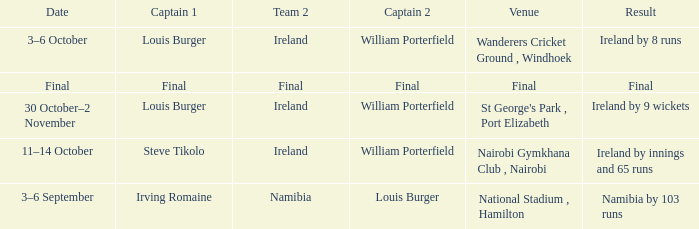Which Result has a Captain 2 of louis burger? Namibia by 103 runs. 